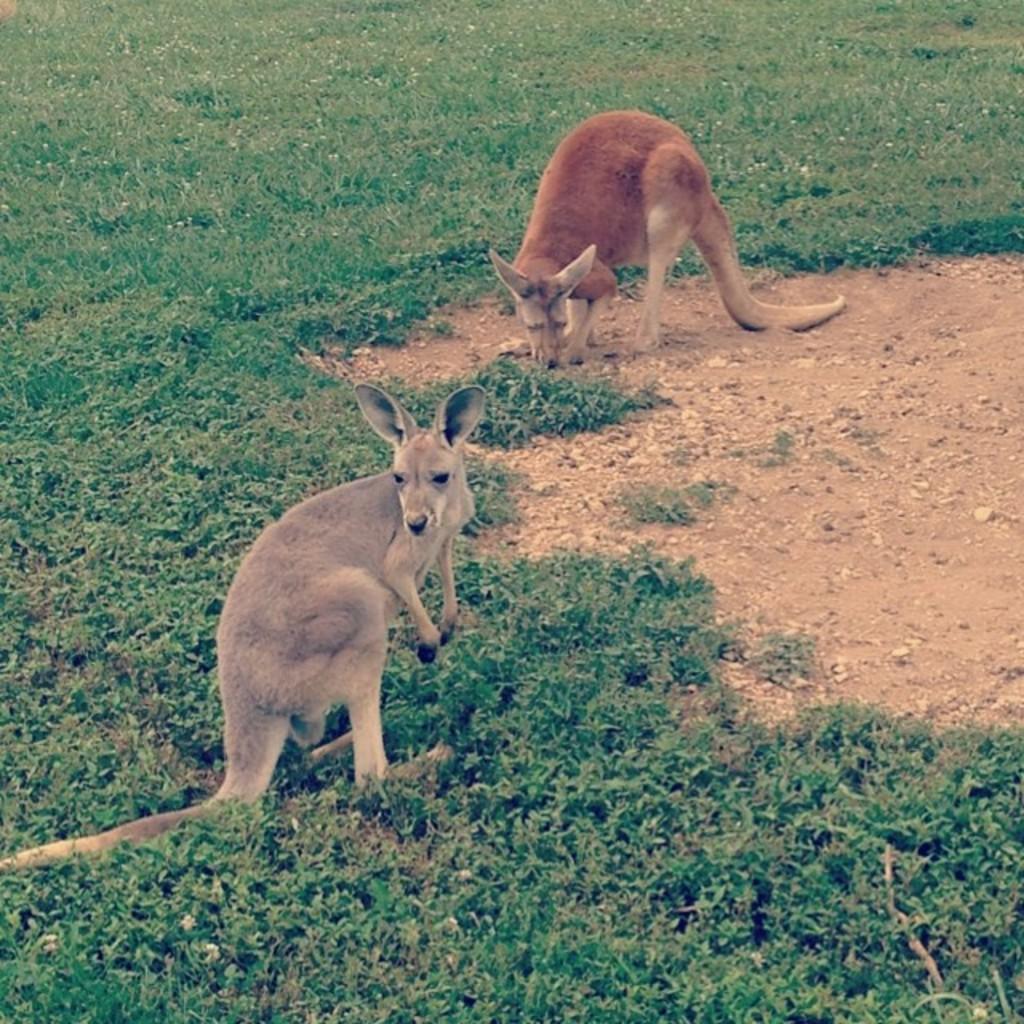Can you describe this image briefly? In this image I can see two kangaroos which are brown, grey and cream in color are standing on the ground. I can see some grass on the ground which is green in color. 